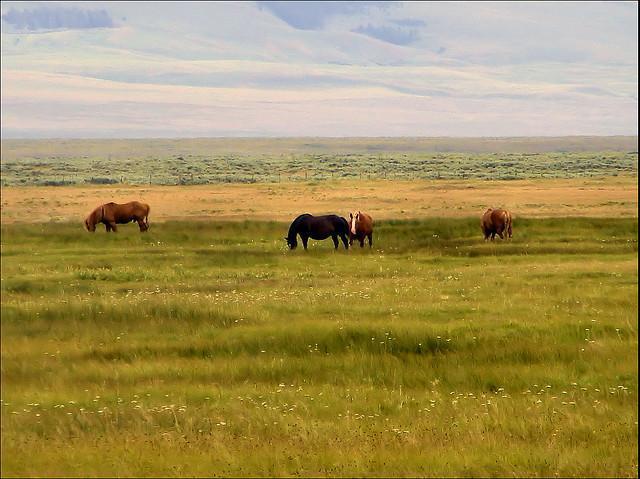How many animals?
Give a very brief answer. 4. 